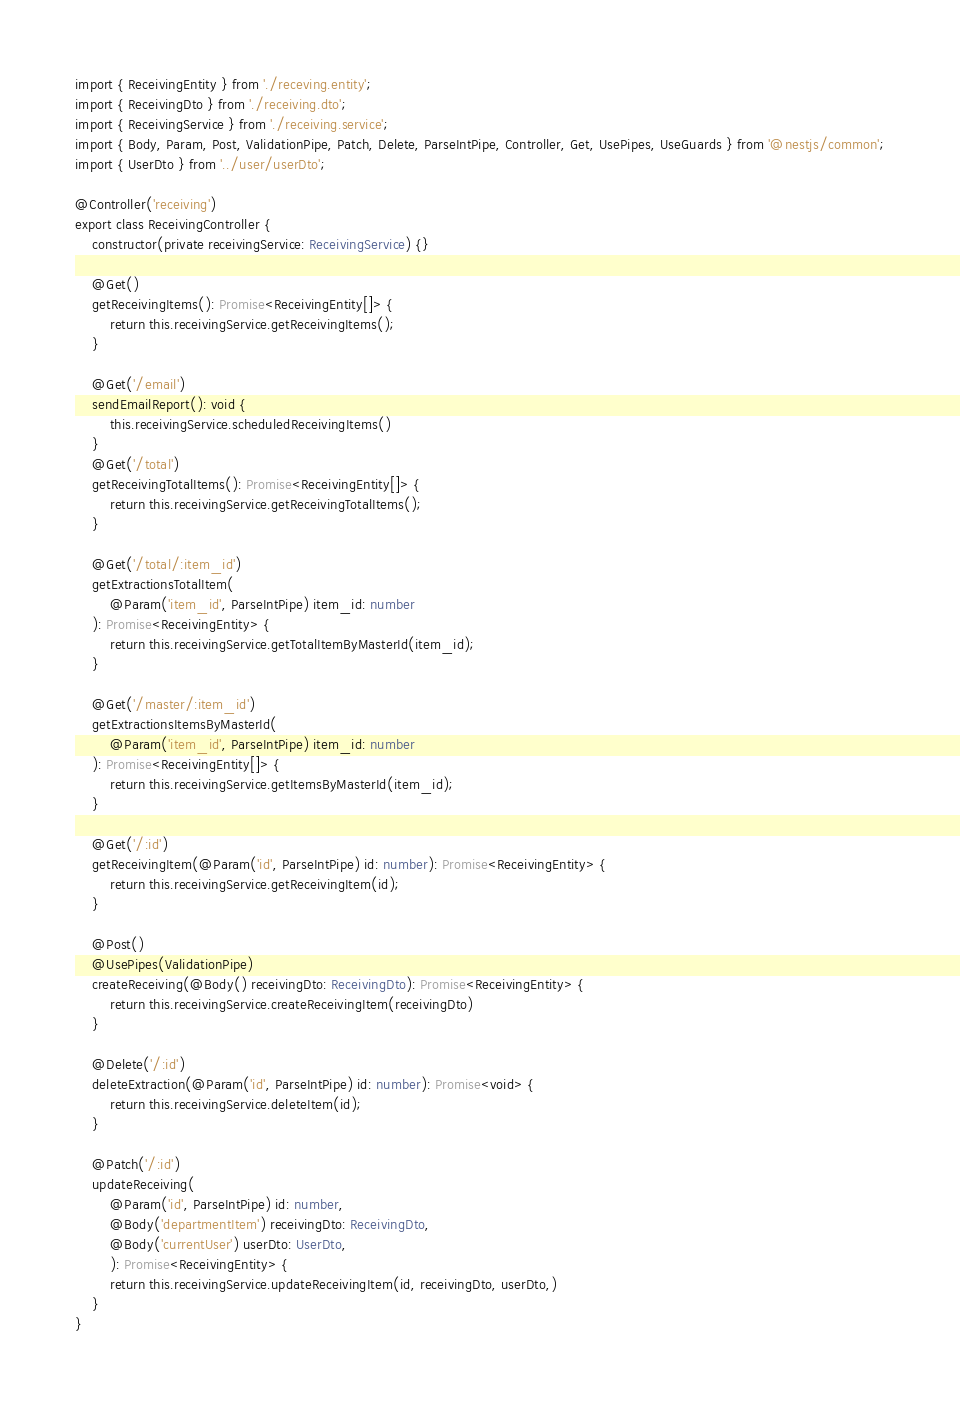<code> <loc_0><loc_0><loc_500><loc_500><_TypeScript_>import { ReceivingEntity } from './receving.entity';
import { ReceivingDto } from './receiving.dto';
import { ReceivingService } from './receiving.service';
import { Body, Param, Post, ValidationPipe, Patch, Delete, ParseIntPipe, Controller, Get, UsePipes, UseGuards } from '@nestjs/common';
import { UserDto } from '../user/userDto';

@Controller('receiving')
export class ReceivingController {
    constructor(private receivingService: ReceivingService) {}

    @Get()
    getReceivingItems(): Promise<ReceivingEntity[]> {
        return this.receivingService.getReceivingItems();
    }
    
    @Get('/email')
    sendEmailReport(): void {
        this.receivingService.scheduledReceivingItems()
    }
    @Get('/total')
    getReceivingTotalItems(): Promise<ReceivingEntity[]> {
        return this.receivingService.getReceivingTotalItems();
    }

    @Get('/total/:item_id')
    getExtractionsTotalItem(
        @Param('item_id', ParseIntPipe) item_id: number
    ): Promise<ReceivingEntity> {
        return this.receivingService.getTotalItemByMasterId(item_id);
    }

    @Get('/master/:item_id')
    getExtractionsItemsByMasterId(
        @Param('item_id', ParseIntPipe) item_id: number
    ): Promise<ReceivingEntity[]> {
        return this.receivingService.getItemsByMasterId(item_id);
    }

    @Get('/:id')
    getReceivingItem(@Param('id', ParseIntPipe) id: number): Promise<ReceivingEntity> {
        return this.receivingService.getReceivingItem(id);
    }

    @Post()
    @UsePipes(ValidationPipe)
    createReceiving(@Body() receivingDto: ReceivingDto): Promise<ReceivingEntity> {
        return this.receivingService.createReceivingItem(receivingDto)
    }

    @Delete('/:id')
    deleteExtraction(@Param('id', ParseIntPipe) id: number): Promise<void> {
        return this.receivingService.deleteItem(id);
    }

    @Patch('/:id')
    updateReceiving(
        @Param('id', ParseIntPipe) id: number, 
        @Body('departmentItem') receivingDto: ReceivingDto,
        @Body('currentUser') userDto: UserDto,
        ): Promise<ReceivingEntity> {
        return this.receivingService.updateReceivingItem(id, receivingDto, userDto,)
    }
}
</code> 